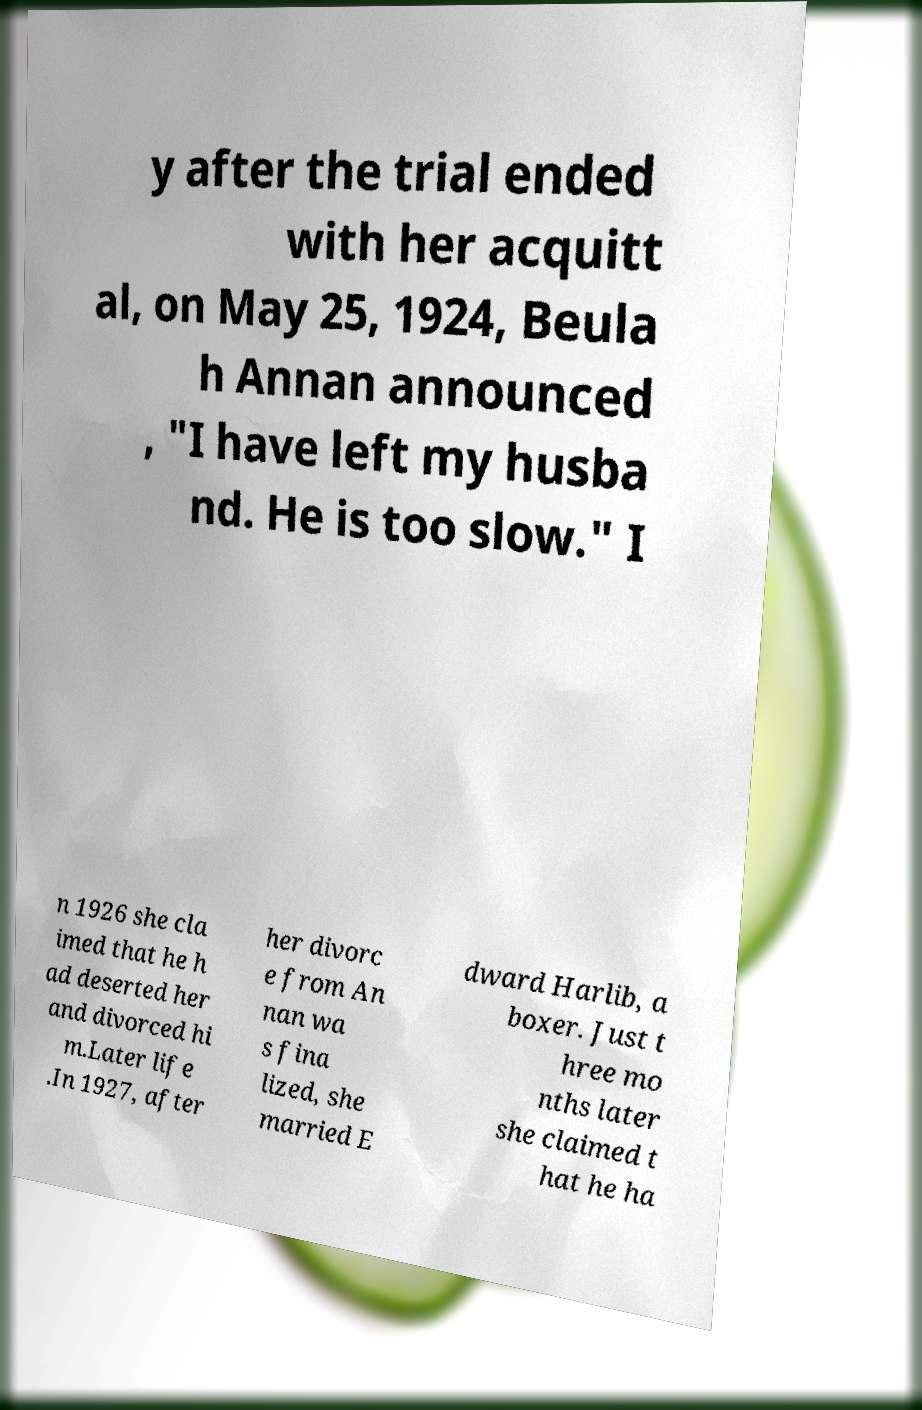Please read and relay the text visible in this image. What does it say? y after the trial ended with her acquitt al, on May 25, 1924, Beula h Annan announced , "I have left my husba nd. He is too slow." I n 1926 she cla imed that he h ad deserted her and divorced hi m.Later life .In 1927, after her divorc e from An nan wa s fina lized, she married E dward Harlib, a boxer. Just t hree mo nths later she claimed t hat he ha 